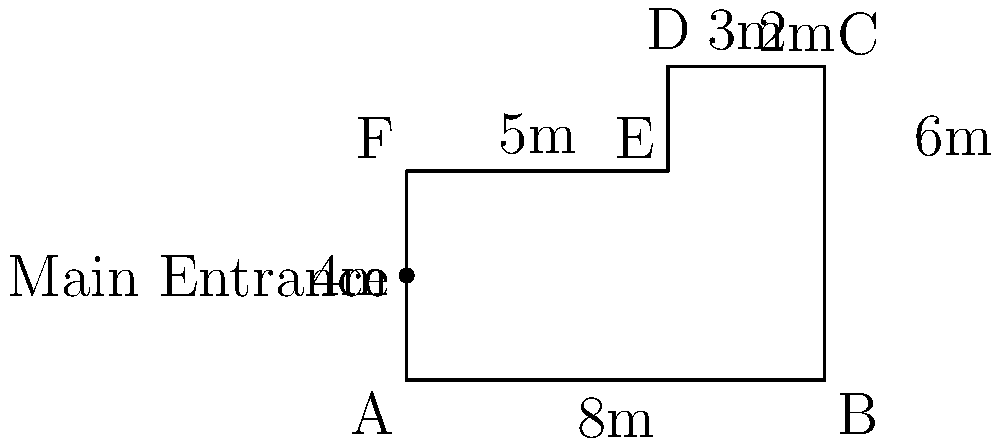The Wiltshire Heritage Museum is planning to renovate its main exhibition hall. The floor plan of the hall is shown in the diagram. If the museum wants to install new carpeting throughout the entire hall, how many square meters of carpet will they need to order? To find the total area of the floor, we need to break it down into simpler shapes and calculate their areas:

1. The floor plan can be divided into a rectangle (ABCF) and a smaller rectangle (CDEF).

2. Area of rectangle ABCF:
   Length = 8m, Width = 4m
   Area_ABCF = $8 \times 4 = 32$ sq m

3. Area of rectangle CDEF:
   Length = 3m, Width = 2m
   Area_CDEF = $3 \times 2 = 6$ sq m

4. Total area = Area_ABCF + Area_CDEF
              = $32 + 6 = 38$ sq m

Therefore, the museum will need to order 38 square meters of carpet to cover the entire exhibition hall floor.
Answer: 38 sq m 